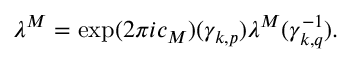<formula> <loc_0><loc_0><loc_500><loc_500>\lambda ^ { M } = \exp ( 2 \pi i c _ { M } ) ( { \gamma } _ { k , p } ) \lambda ^ { M } ( { \gamma } _ { k , q } ^ { - 1 } ) .</formula> 